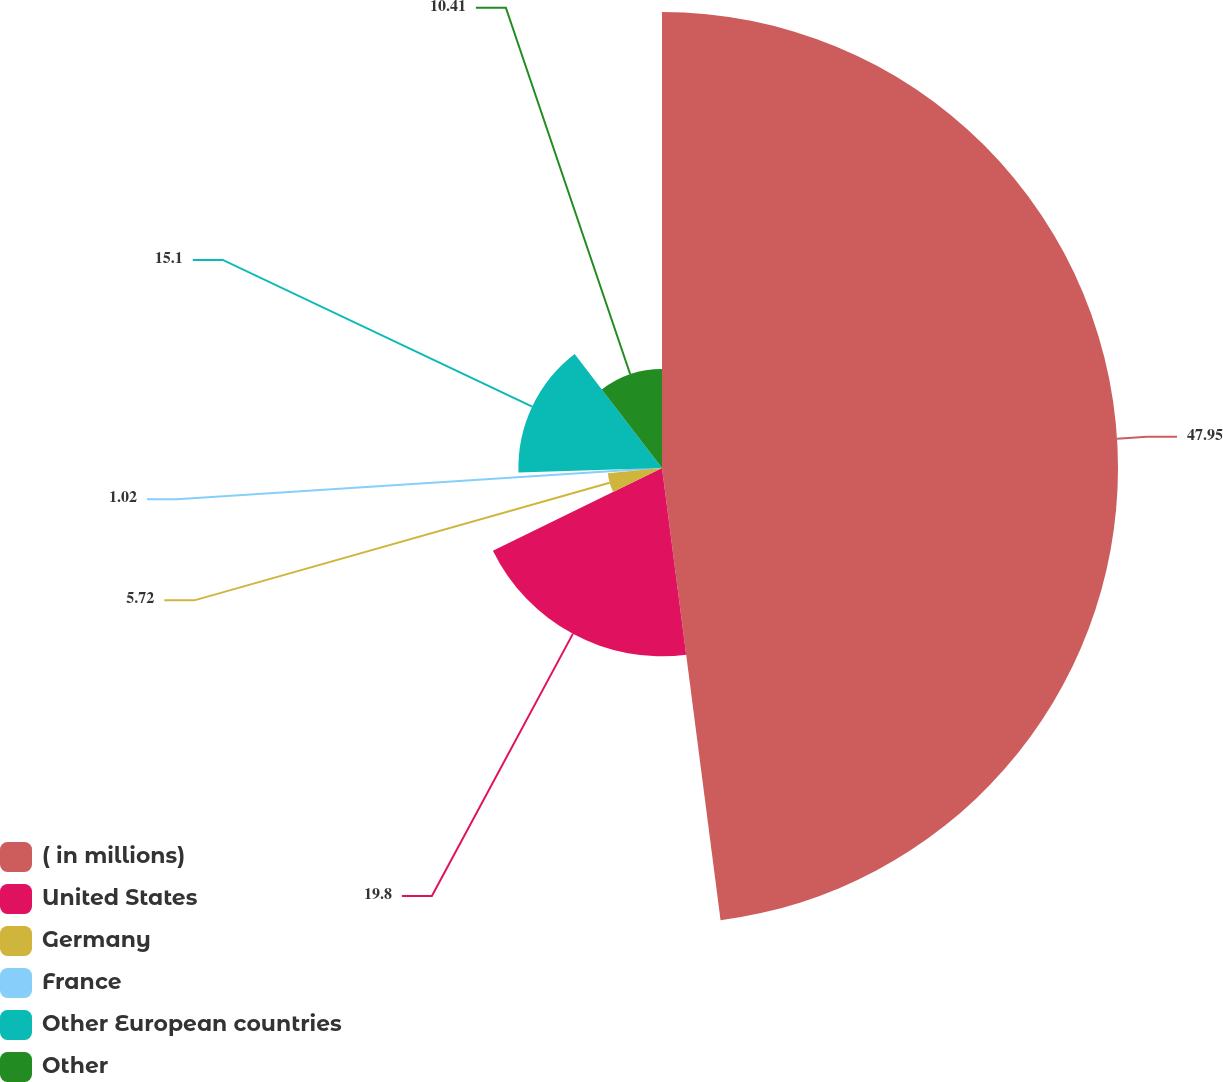Convert chart. <chart><loc_0><loc_0><loc_500><loc_500><pie_chart><fcel>( in millions)<fcel>United States<fcel>Germany<fcel>France<fcel>Other European countries<fcel>Other<nl><fcel>47.95%<fcel>19.8%<fcel>5.72%<fcel>1.02%<fcel>15.1%<fcel>10.41%<nl></chart> 